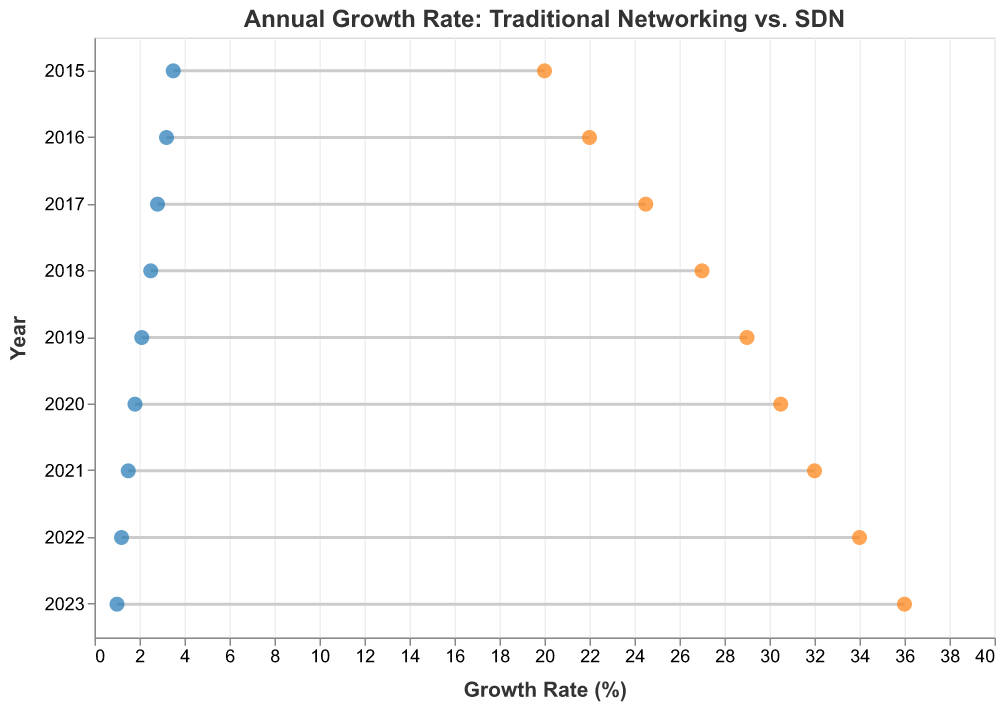What is the title of the figure? The title is located at the top of the figure. It reads "Annual Growth Rate: Traditional Networking vs. SDN"
Answer: Annual Growth Rate: Traditional Networking vs. SDN What are the two different types of networking growth rates compared in the plot? The figure compares "Traditional Networking Growth Rate" and "SDN Growth Rate," which are indicated on the x-axis and with different colored points.
Answer: Traditional Networking Growth Rate and SDN Growth Rate What trend can be observed in the growth rate of traditional networking from 2015 to 2023? By looking at the blue points representing Traditional Networking Growth Rates from 2015 to 2023, we can see a clear downward trend.
Answer: Downward trend How does the growth rate of SDN in 2023 compare to that in 2015? The orange points represent the SDN Growth Rates. In 2023, it is 36.0%, and in 2015, it is 20.0%.
Answer: 36.0% vs. 20.0% By how much did the SDN growth rate increase from 2015 to 2023? To find the increase, subtract the SDN growth rate in 2015 (20.0%) from that in 2023 (36.0%). So, 36.0% - 20.0% = 16.0%.
Answer: 16.0% Which year has the smallest difference between the growth rates of traditional networking and SDN? To find the smallest difference, compare the differences between each pair of growth rates for all years. The smallest difference is in 2015 (20.0% - 3.5% = 16.5%).
Answer: 2015 What is the difference between the traditional networking and SDN growth rates in 2021? The traditional networking growth rate in 2021 is 1.5%, and the SDN growth rate is 32.0%. The difference is 32.0% - 1.5% = 30.5%.
Answer: 30.5% In which year did the traditional networking growth rate fall below 2%? By examining the blue points, we see that the traditional networking growth rate fell below 2% starting in 2019.
Answer: 2019 What year shows the highest growth rate for SDN? The orange points indicate SDN Growth Rates across the years. The maximum value for SDN is 36.0% in 2023.
Answer: 2023 If you average the traditional networking growth rates from 2015 to 2023, what is the result? Sum all traditional networking growth rates: 3.5 + 3.2 + 2.8 + 2.5 + 2.1 + 1.8 + 1.5 + 1.2 + 1.0 = 19.6. The average is 19.6 / 9 = 2.18 (approx.).
Answer: 2.18 (approx.) 